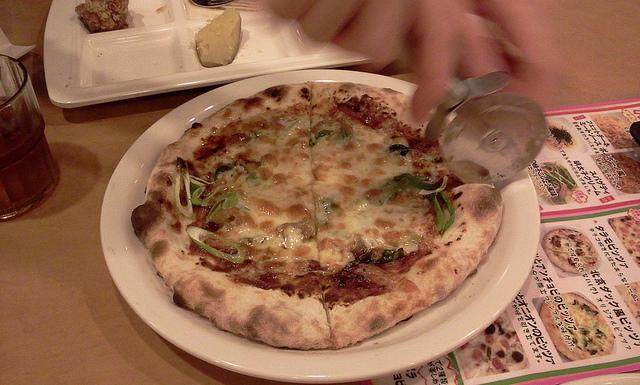In which style white pizza made of? italian 